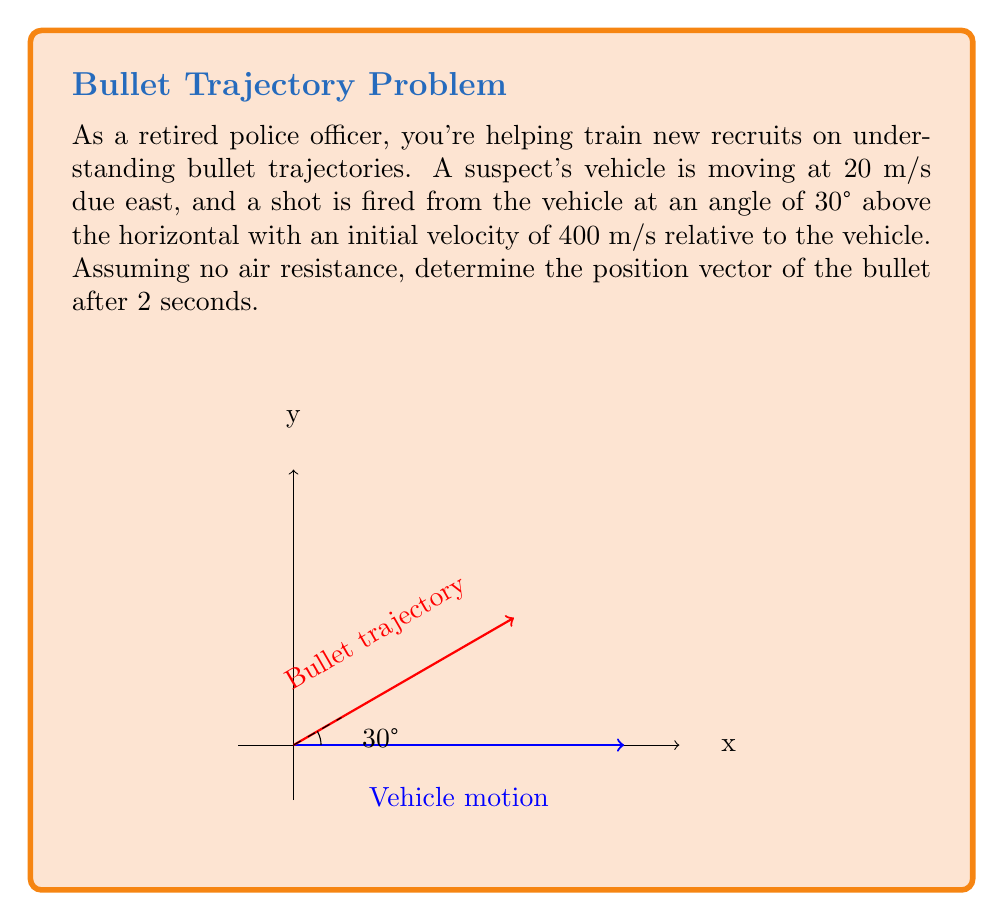What is the answer to this math problem? Let's approach this step-by-step:

1) First, we need to consider that the bullet's motion is a combination of two vectors:
   a) The vehicle's motion
   b) The bullet's motion relative to the vehicle

2) The vehicle's motion:
   $$\vec{v}_v = 20\hat{i} \text{ m/s}$$
   After 2 seconds, the displacement due to the vehicle's motion is:
   $$\vec{r}_v = 20t\hat{i} = 40\hat{i} \text{ m}$$

3) The bullet's motion relative to the vehicle:
   Initial velocity components:
   $$v_x = 400 \cos(30°) = 400 \cdot \frac{\sqrt{3}}{2} = 200\sqrt{3} \text{ m/s}$$
   $$v_y = 400 \sin(30°) = 400 \cdot \frac{1}{2} = 200 \text{ m/s}$$

4) Using the kinematic equations for constant acceleration (g = 9.8 m/s²):
   $$x = v_xt = 200\sqrt{3} \cdot 2 = 400\sqrt{3} \text{ m}$$
   $$y = v_yt - \frac{1}{2}gt^2 = 200 \cdot 2 - \frac{1}{2} \cdot 9.8 \cdot 2^2 = 380.4 \text{ m}$$

5) The bullet's position relative to its firing point:
   $$\vec{r}_b = 400\sqrt{3}\hat{i} + 380.4\hat{j} \text{ m}$$

6) The total position vector is the sum of the vehicle's displacement and the bullet's relative position:
   $$\vec{r} = \vec{r}_v + \vec{r}_b = (40 + 400\sqrt{3})\hat{i} + 380.4\hat{j} \text{ m}$$
Answer: $$(40 + 400\sqrt{3})\hat{i} + 380.4\hat{j} \text{ m}$$ 